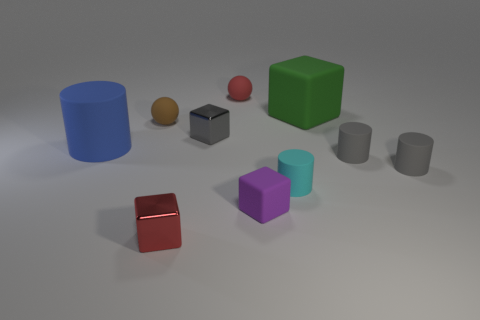What number of things are either small red balls that are behind the tiny brown matte thing or small objects?
Provide a short and direct response. 8. There is a tiny red object left of the red object behind the blue rubber thing; what shape is it?
Provide a short and direct response. Cube. Are there any red matte objects that have the same size as the purple rubber thing?
Your answer should be very brief. Yes. Is the number of brown rubber spheres greater than the number of small yellow matte spheres?
Your response must be concise. Yes. Is the size of the metal object on the left side of the gray metal block the same as the sphere that is in front of the large cube?
Give a very brief answer. Yes. How many things are in front of the small purple thing and behind the big blue rubber cylinder?
Your response must be concise. 0. There is another thing that is the same shape as the small red matte object; what is its color?
Ensure brevity in your answer.  Brown. Are there fewer big blue matte objects than tiny green metallic cylinders?
Offer a terse response. No. Do the blue cylinder and the brown rubber thing behind the small purple thing have the same size?
Give a very brief answer. No. There is a large object behind the large thing left of the small red matte object; what color is it?
Keep it short and to the point. Green. 